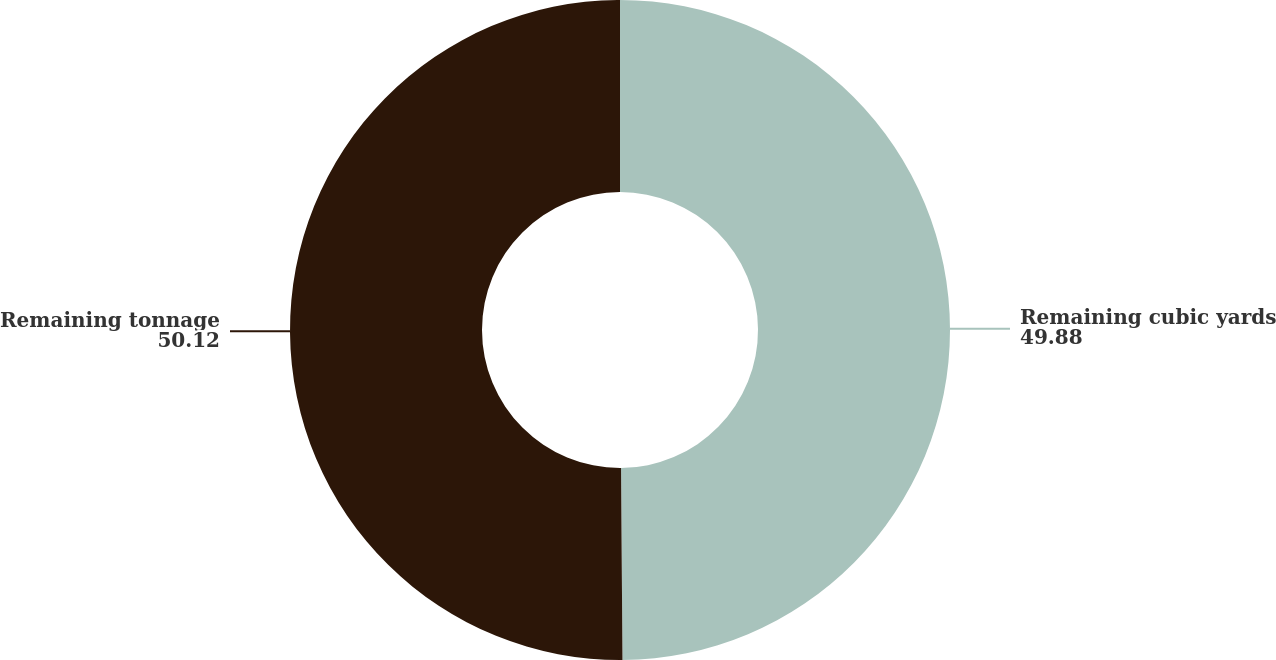Convert chart. <chart><loc_0><loc_0><loc_500><loc_500><pie_chart><fcel>Remaining cubic yards<fcel>Remaining tonnage<nl><fcel>49.88%<fcel>50.12%<nl></chart> 